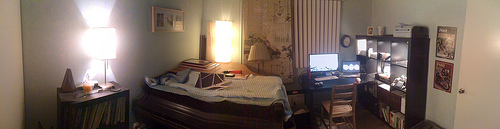Can you describe any plants visible in the room? It appears that there are no live plants visible within the room's immediate view. However, the presence of plants would add a fresh, natural element to the space, possibly improving air quality and the overall aesthetic. 